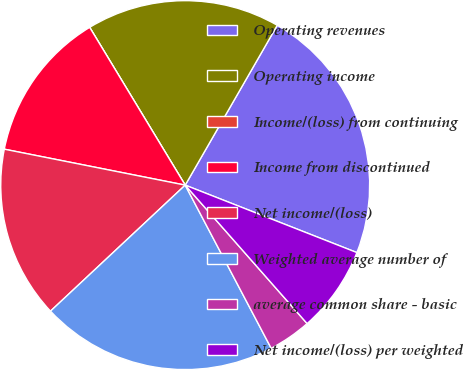Convert chart. <chart><loc_0><loc_0><loc_500><loc_500><pie_chart><fcel>Operating revenues<fcel>Operating income<fcel>Income/(loss) from continuing<fcel>Income from discontinued<fcel>Net income/(loss)<fcel>Weighted average number of<fcel>average common share - basic<fcel>Net income/(loss) per weighted<nl><fcel>22.64%<fcel>16.98%<fcel>0.0%<fcel>13.21%<fcel>15.09%<fcel>20.75%<fcel>3.77%<fcel>7.55%<nl></chart> 